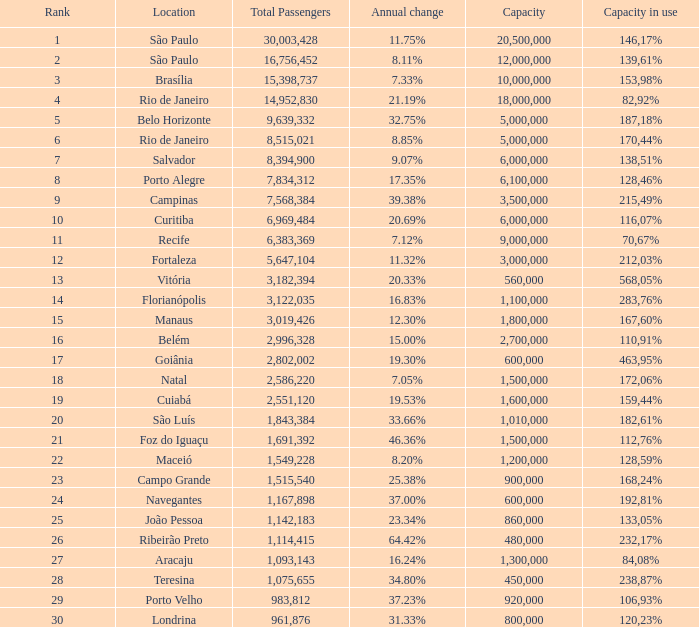60%? 1800000.0. 